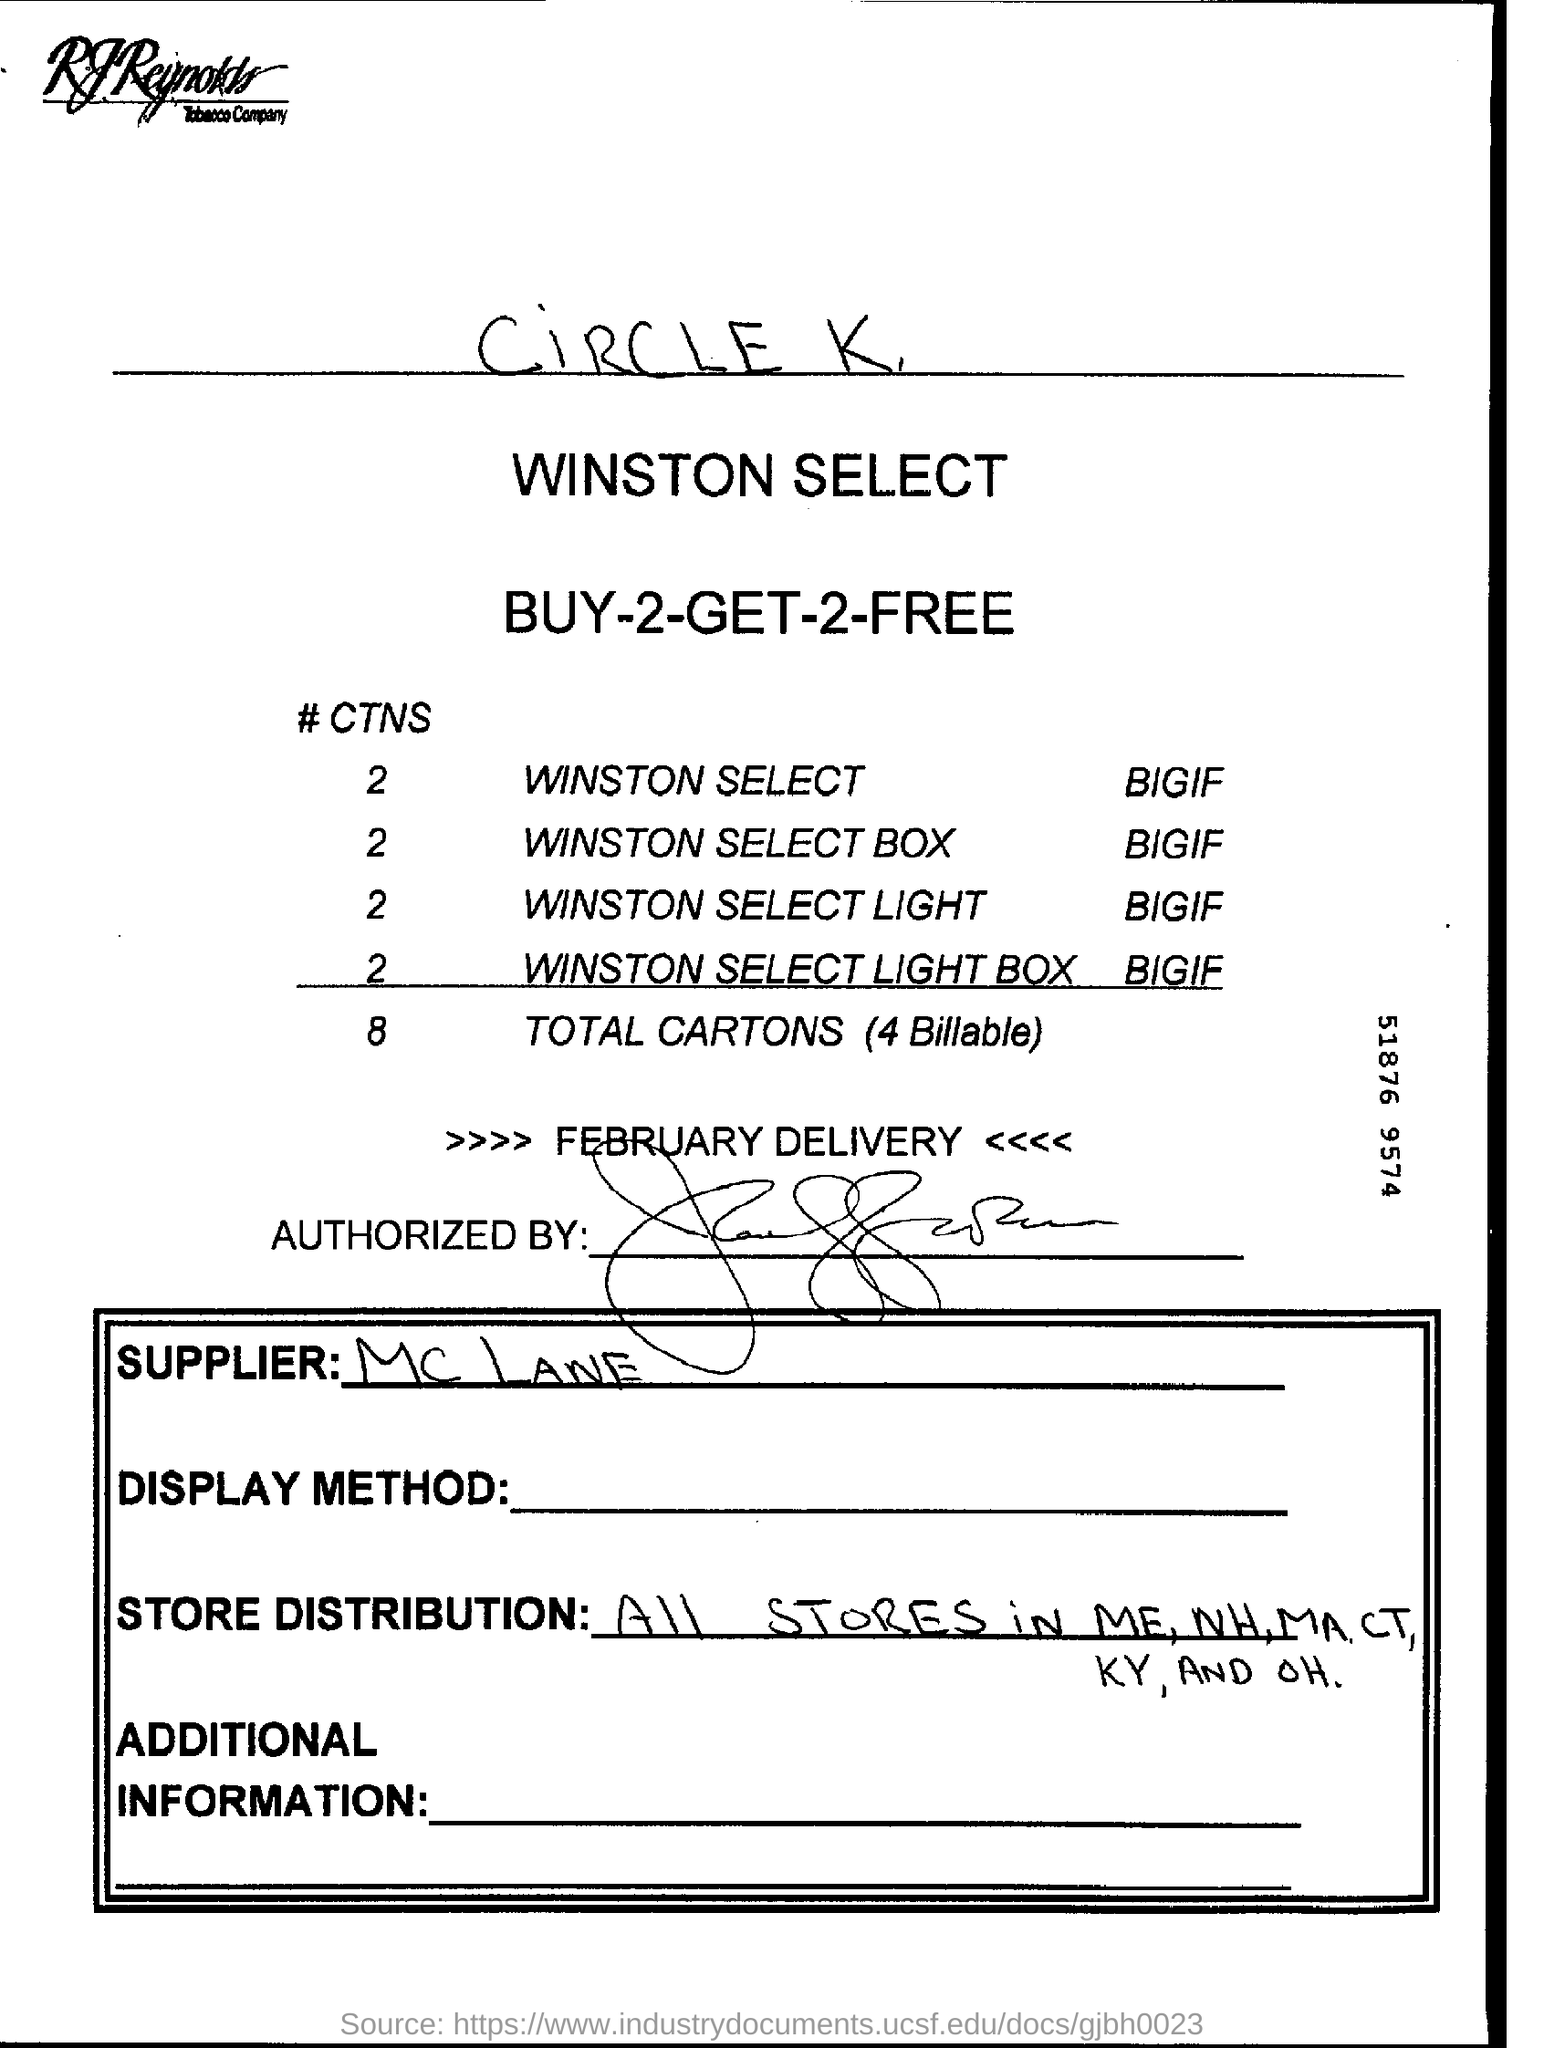Mention a couple of crucial points in this snapshot. The delivery mentioned on this page is in February. The handwriting at the top of the page is from a circle K, and it contains important information. 